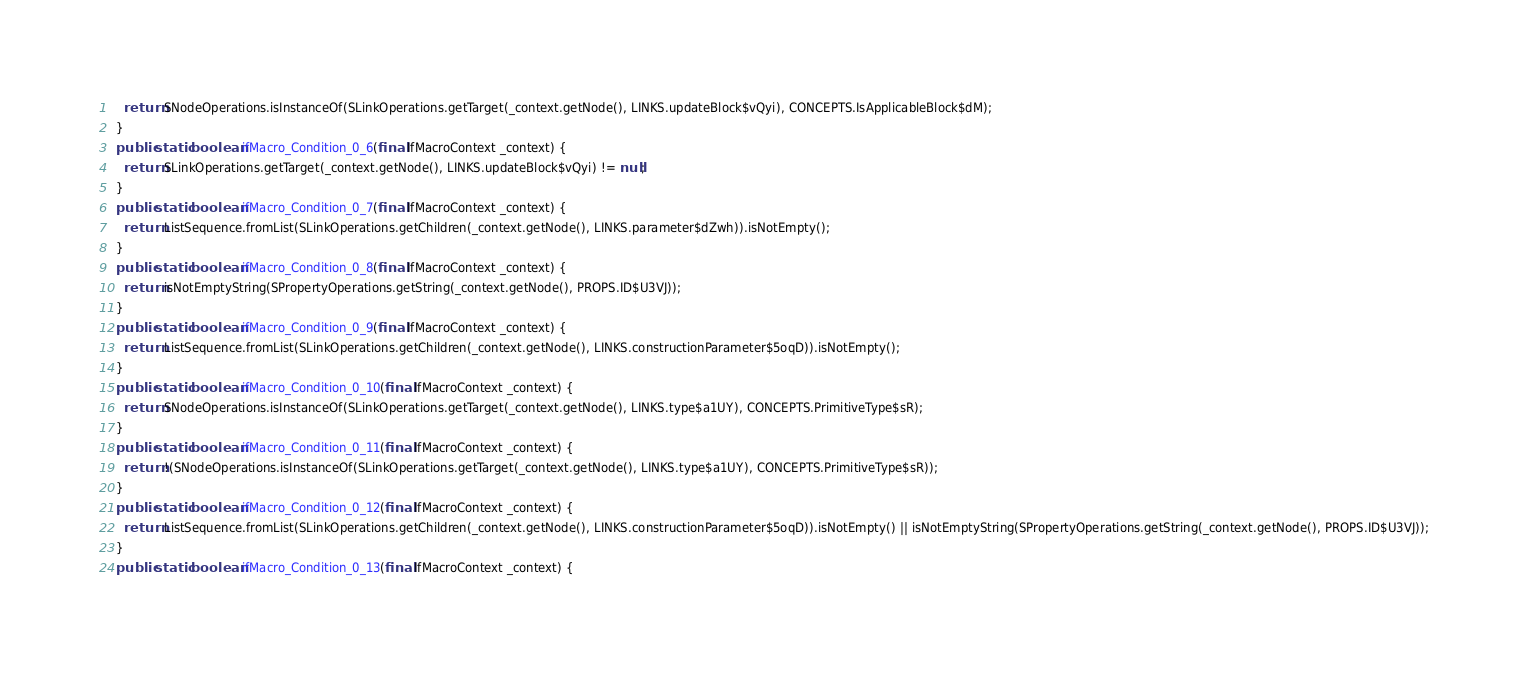<code> <loc_0><loc_0><loc_500><loc_500><_Java_>    return SNodeOperations.isInstanceOf(SLinkOperations.getTarget(_context.getNode(), LINKS.updateBlock$vQyi), CONCEPTS.IsApplicableBlock$dM);
  }
  public static boolean ifMacro_Condition_0_6(final IfMacroContext _context) {
    return SLinkOperations.getTarget(_context.getNode(), LINKS.updateBlock$vQyi) != null;
  }
  public static boolean ifMacro_Condition_0_7(final IfMacroContext _context) {
    return ListSequence.fromList(SLinkOperations.getChildren(_context.getNode(), LINKS.parameter$dZwh)).isNotEmpty();
  }
  public static boolean ifMacro_Condition_0_8(final IfMacroContext _context) {
    return isNotEmptyString(SPropertyOperations.getString(_context.getNode(), PROPS.ID$U3VJ));
  }
  public static boolean ifMacro_Condition_0_9(final IfMacroContext _context) {
    return ListSequence.fromList(SLinkOperations.getChildren(_context.getNode(), LINKS.constructionParameter$5oqD)).isNotEmpty();
  }
  public static boolean ifMacro_Condition_0_10(final IfMacroContext _context) {
    return SNodeOperations.isInstanceOf(SLinkOperations.getTarget(_context.getNode(), LINKS.type$a1UY), CONCEPTS.PrimitiveType$sR);
  }
  public static boolean ifMacro_Condition_0_11(final IfMacroContext _context) {
    return !(SNodeOperations.isInstanceOf(SLinkOperations.getTarget(_context.getNode(), LINKS.type$a1UY), CONCEPTS.PrimitiveType$sR));
  }
  public static boolean ifMacro_Condition_0_12(final IfMacroContext _context) {
    return ListSequence.fromList(SLinkOperations.getChildren(_context.getNode(), LINKS.constructionParameter$5oqD)).isNotEmpty() || isNotEmptyString(SPropertyOperations.getString(_context.getNode(), PROPS.ID$U3VJ));
  }
  public static boolean ifMacro_Condition_0_13(final IfMacroContext _context) {</code> 